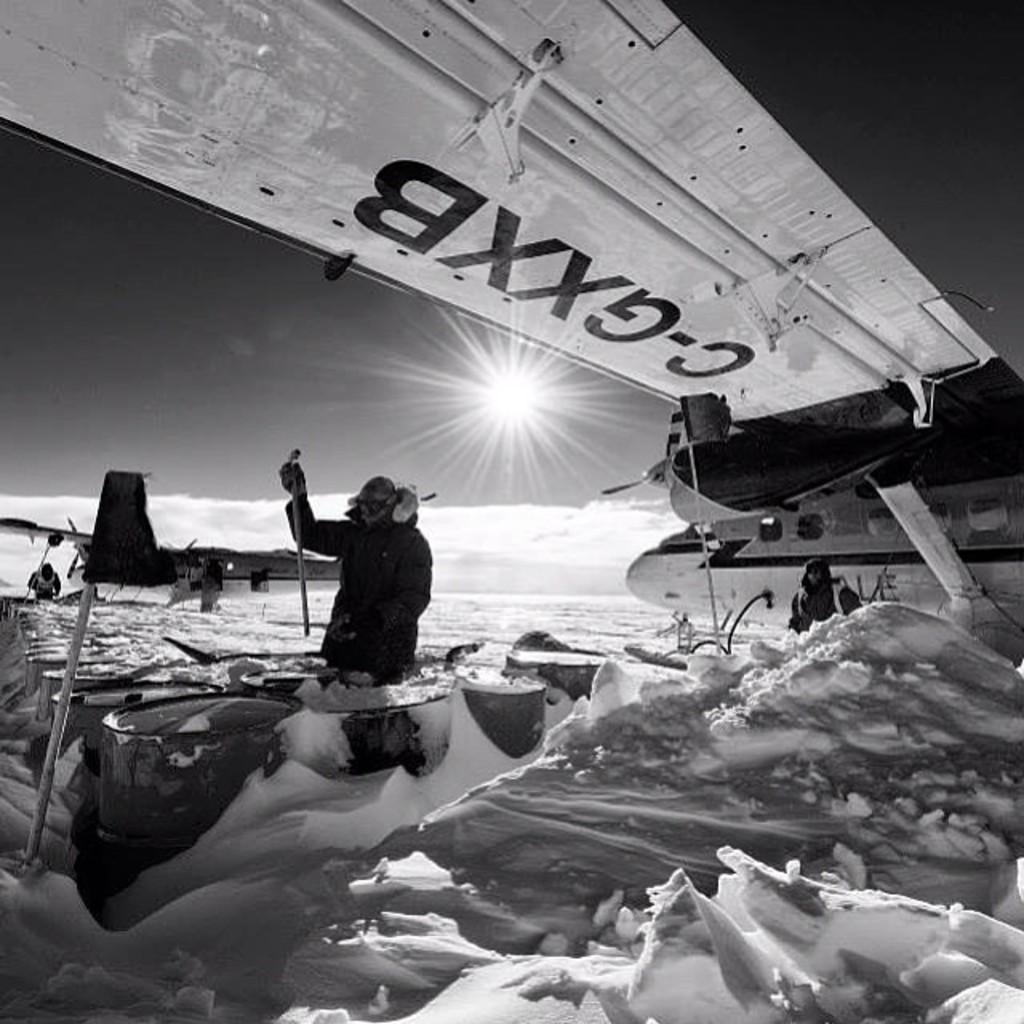<image>
Share a concise interpretation of the image provided. A man standing in the snow below the wing of a plane lettered C-GXXB. 